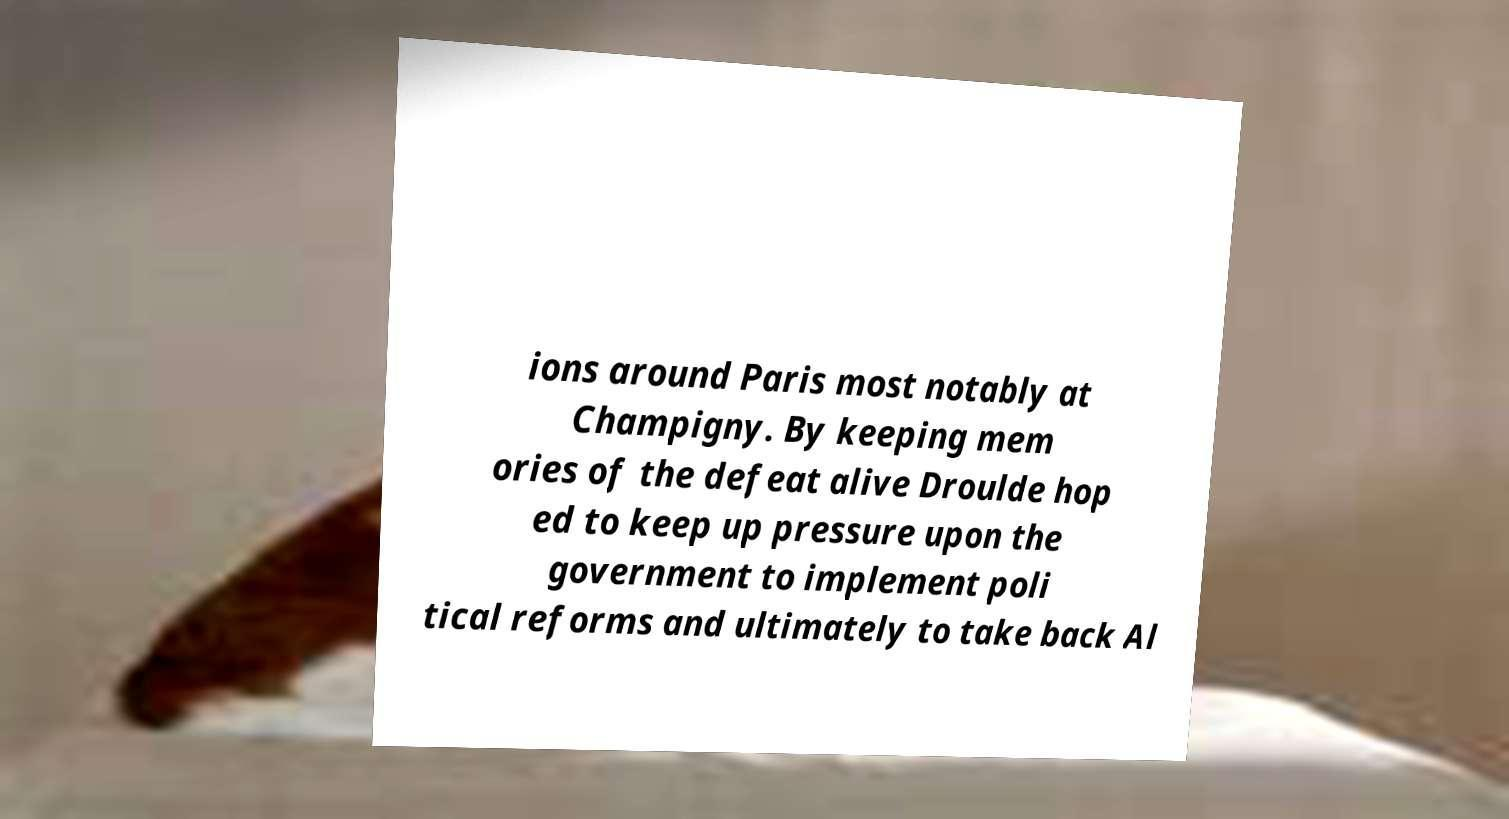Can you read and provide the text displayed in the image?This photo seems to have some interesting text. Can you extract and type it out for me? ions around Paris most notably at Champigny. By keeping mem ories of the defeat alive Droulde hop ed to keep up pressure upon the government to implement poli tical reforms and ultimately to take back Al 